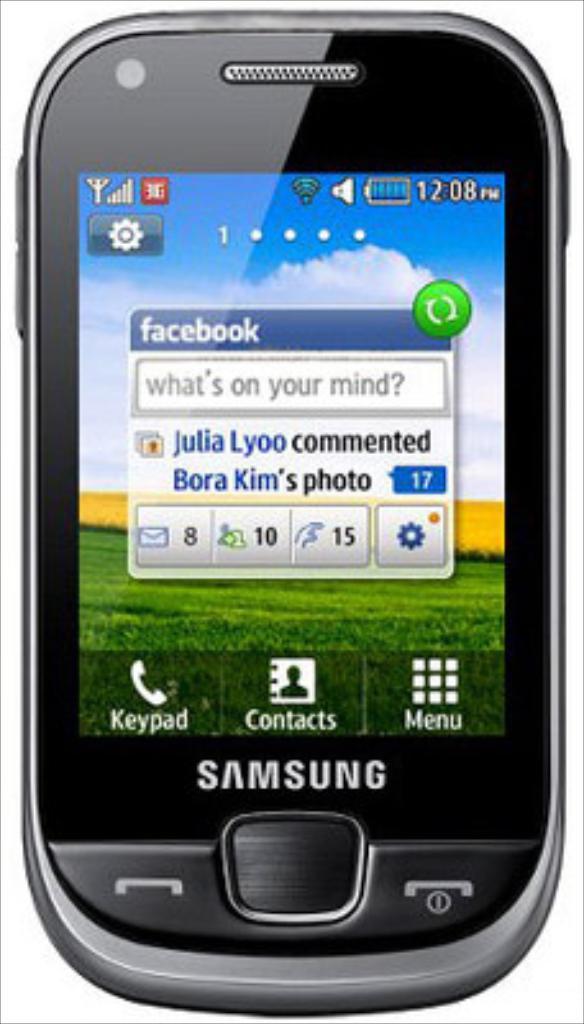Who commented on the photo?
Offer a terse response. Julia lyoo. What brand is this phone?
Provide a succinct answer. Samsung. 